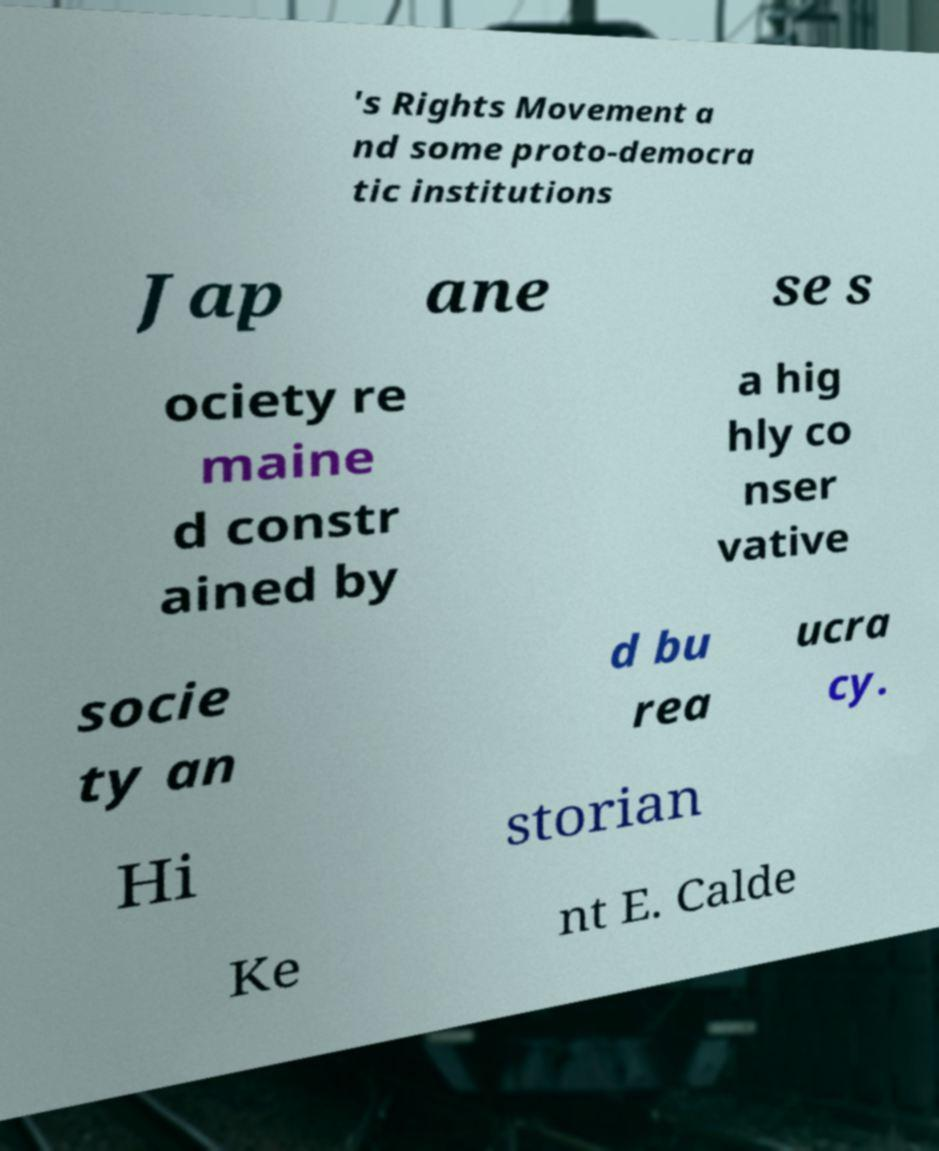Please read and relay the text visible in this image. What does it say? 's Rights Movement a nd some proto-democra tic institutions Jap ane se s ociety re maine d constr ained by a hig hly co nser vative socie ty an d bu rea ucra cy. Hi storian Ke nt E. Calde 